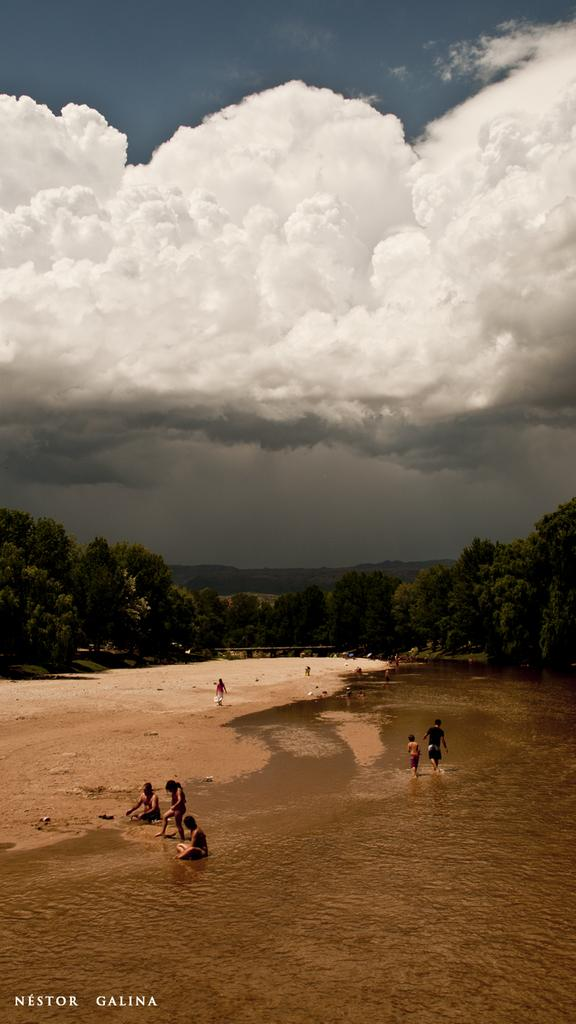What is the primary element in the image? There is water in the image. Are there any living beings present in the image? Yes, there are people in the image. What can be seen beneath the water and people? The ground is visible in the image. What type of natural environment is depicted in the image? There are trees and hills in the image, indicating a natural setting. What is visible above the water and people? The sky is visible in the image, and clouds are present in the sky. What type of skirt is being worn by the trees in the image? There are no skirts present in the image, as trees do not wear clothing. 